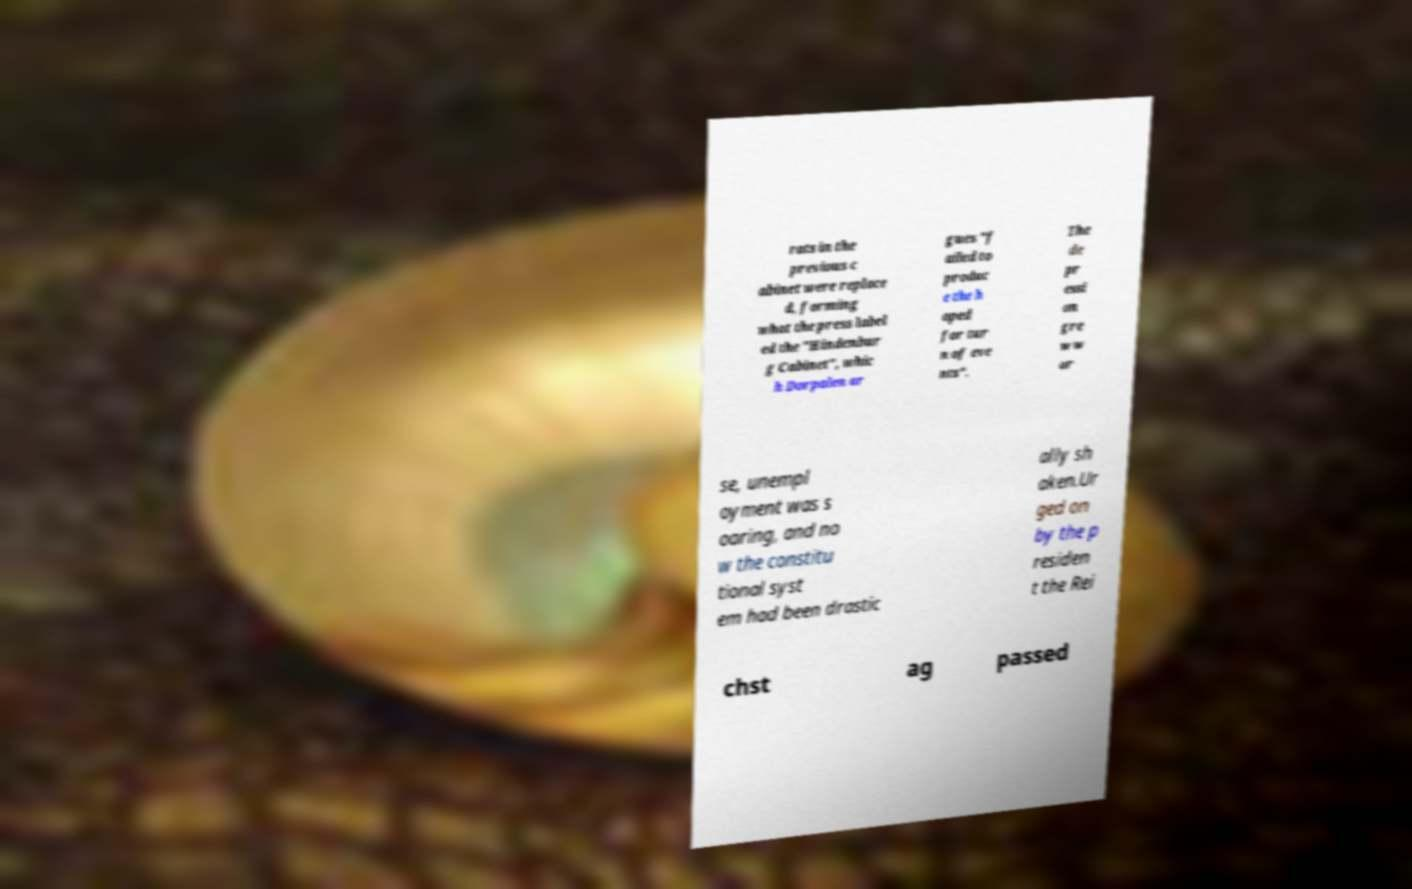Can you read and provide the text displayed in the image?This photo seems to have some interesting text. Can you extract and type it out for me? rats in the previous c abinet were replace d, forming what the press label ed the "Hindenbur g Cabinet", whic h Dorpalen ar gues "f ailed to produc e the h oped for tur n of eve nts". The de pr essi on gre w w or se, unempl oyment was s oaring, and no w the constitu tional syst em had been drastic ally sh aken.Ur ged on by the p residen t the Rei chst ag passed 